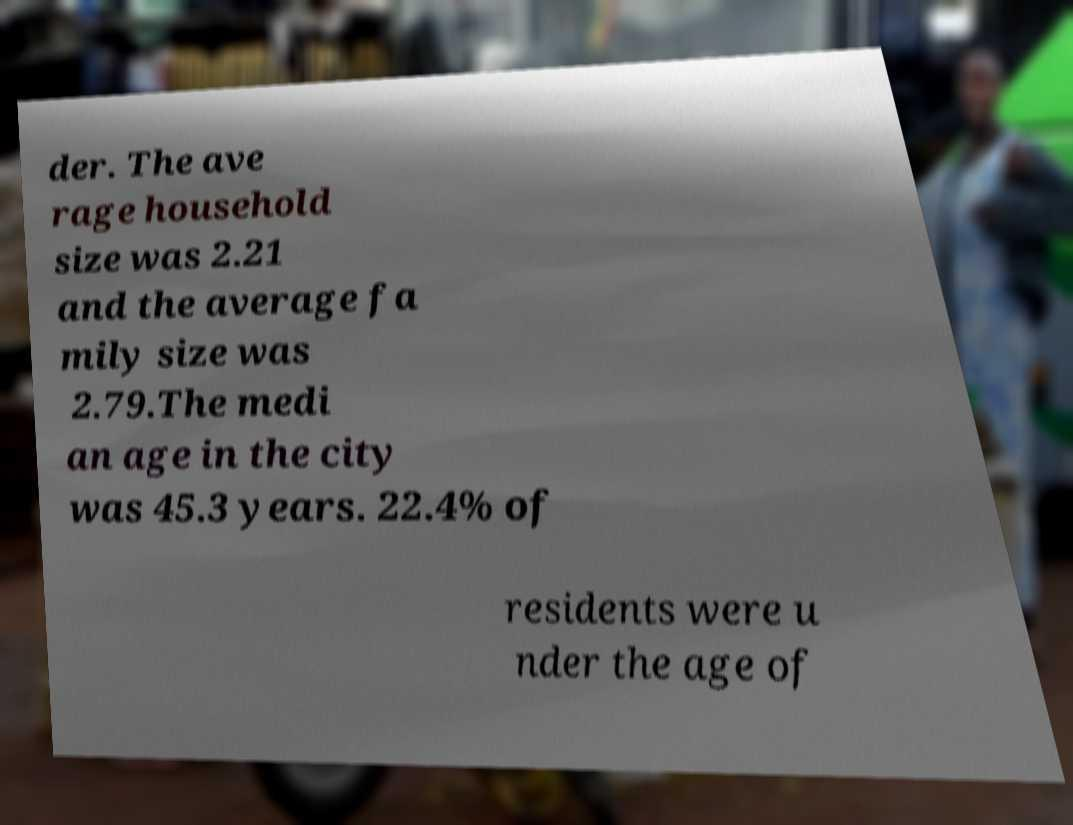Could you extract and type out the text from this image? der. The ave rage household size was 2.21 and the average fa mily size was 2.79.The medi an age in the city was 45.3 years. 22.4% of residents were u nder the age of 